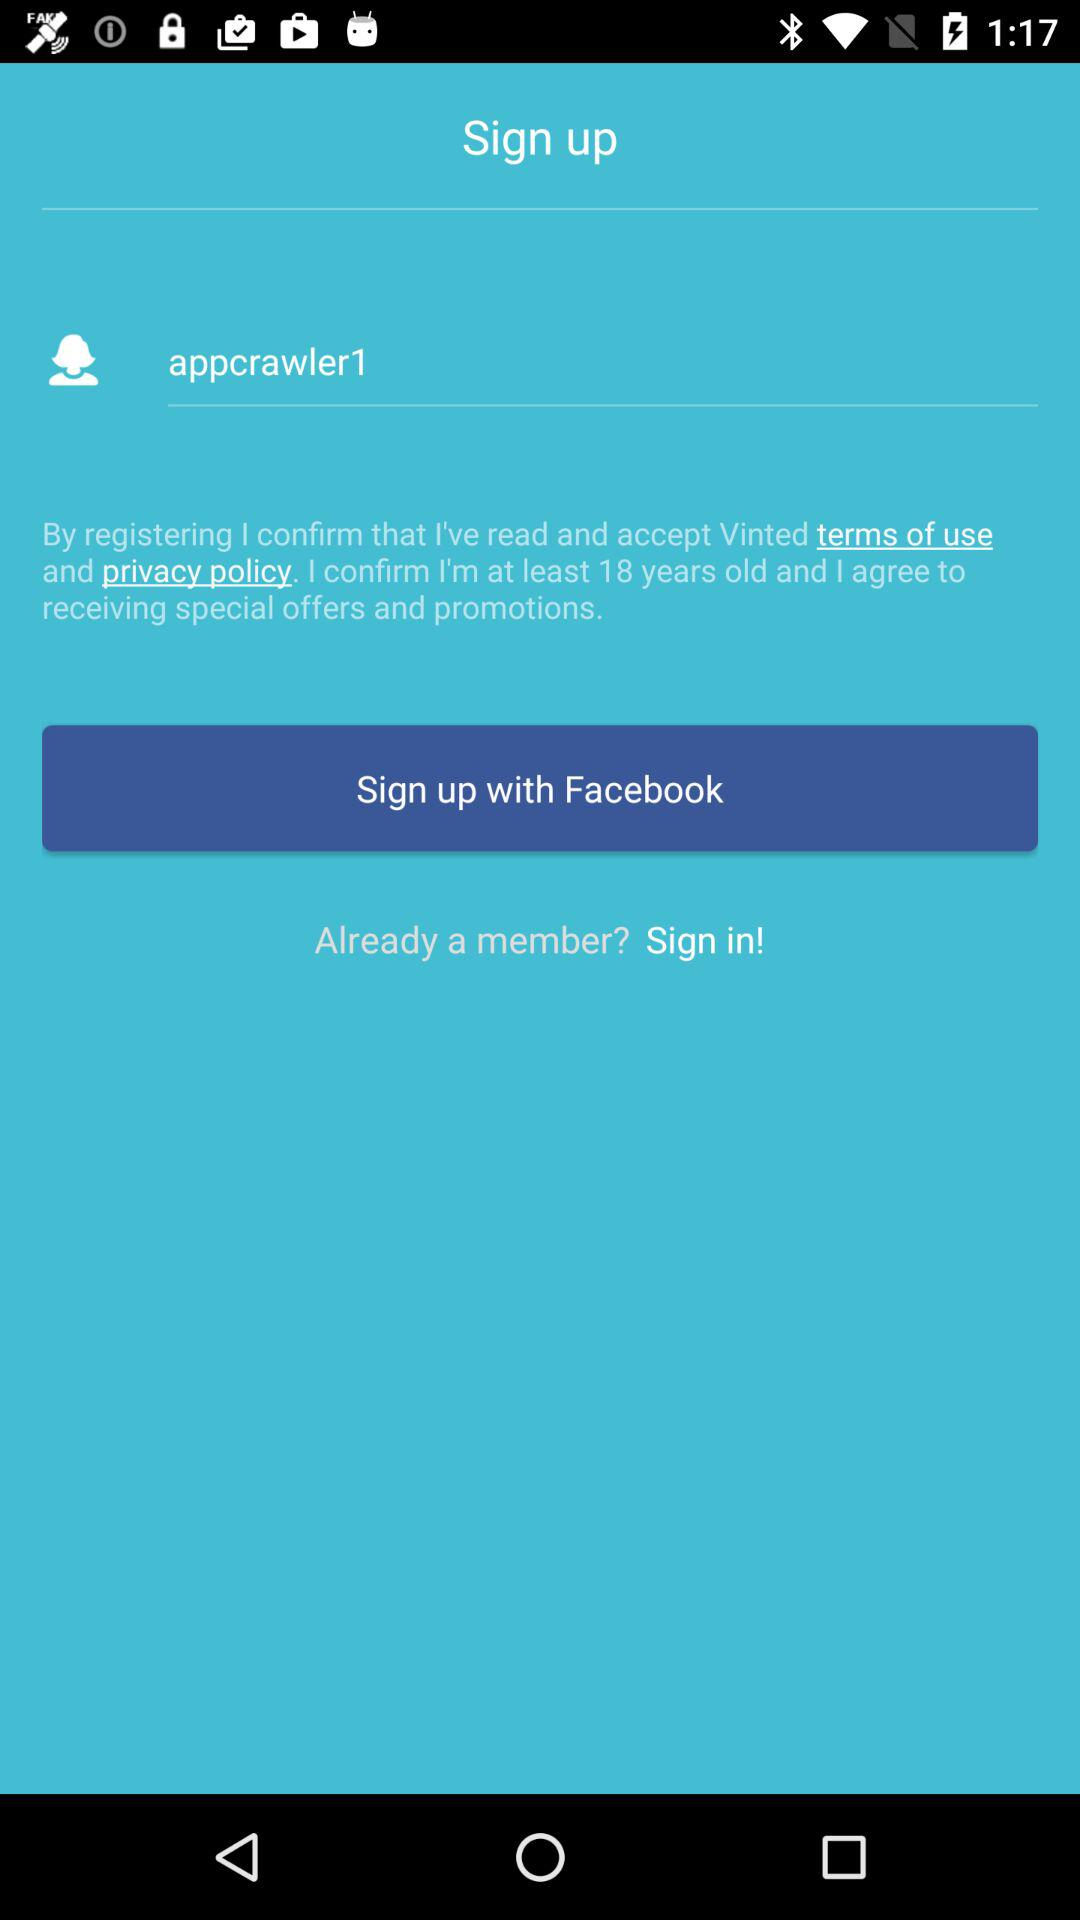What is the username? The username is "appcrawler1". 